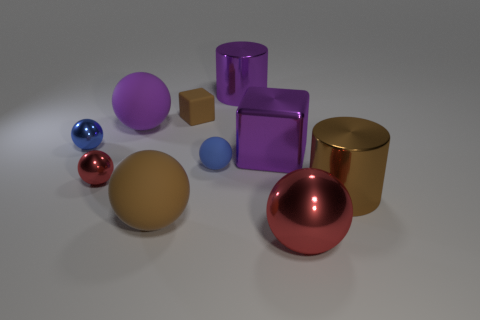Can you tell me the colors of the three spheres in the image? Certainly! From left to right, the colors of the three spheres are blue, gold, and red. 